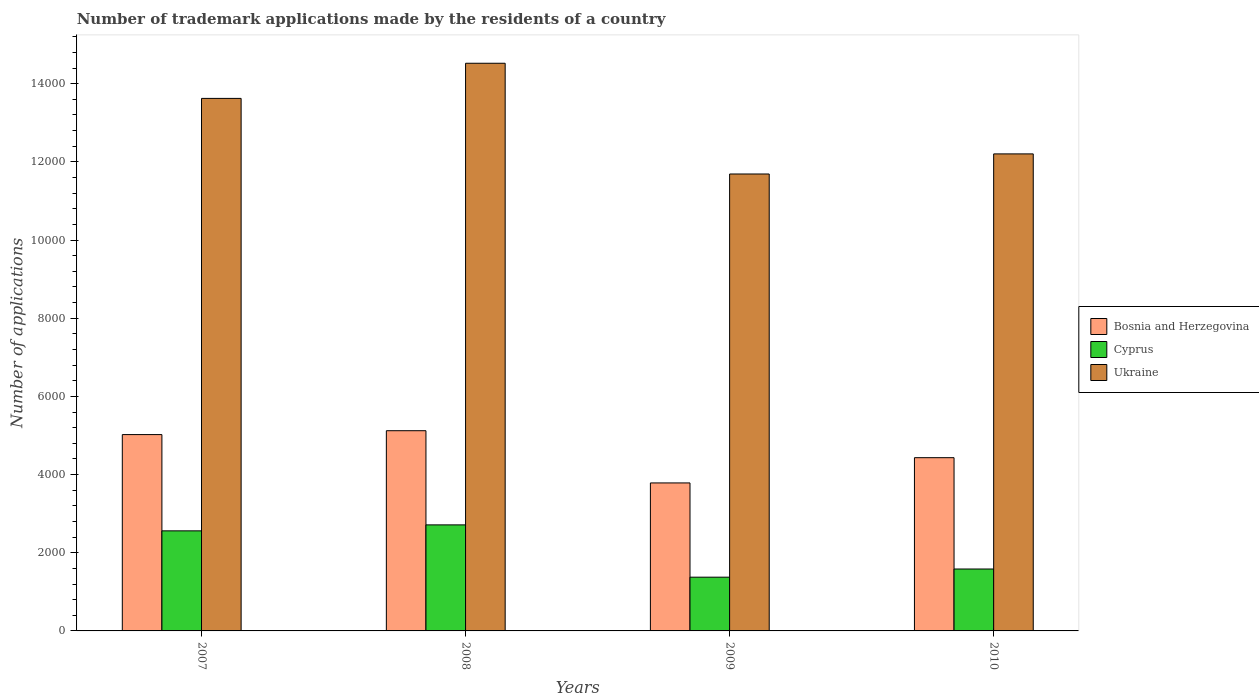Are the number of bars per tick equal to the number of legend labels?
Offer a very short reply. Yes. Are the number of bars on each tick of the X-axis equal?
Provide a succinct answer. Yes. How many bars are there on the 1st tick from the right?
Your response must be concise. 3. In how many cases, is the number of bars for a given year not equal to the number of legend labels?
Give a very brief answer. 0. What is the number of trademark applications made by the residents in Ukraine in 2008?
Make the answer very short. 1.45e+04. Across all years, what is the maximum number of trademark applications made by the residents in Cyprus?
Offer a terse response. 2713. Across all years, what is the minimum number of trademark applications made by the residents in Cyprus?
Ensure brevity in your answer.  1375. What is the total number of trademark applications made by the residents in Bosnia and Herzegovina in the graph?
Make the answer very short. 1.84e+04. What is the difference between the number of trademark applications made by the residents in Cyprus in 2008 and that in 2009?
Your answer should be very brief. 1338. What is the difference between the number of trademark applications made by the residents in Bosnia and Herzegovina in 2010 and the number of trademark applications made by the residents in Cyprus in 2009?
Keep it short and to the point. 3057. What is the average number of trademark applications made by the residents in Bosnia and Herzegovina per year?
Your response must be concise. 4590.75. In the year 2008, what is the difference between the number of trademark applications made by the residents in Ukraine and number of trademark applications made by the residents in Bosnia and Herzegovina?
Make the answer very short. 9401. In how many years, is the number of trademark applications made by the residents in Cyprus greater than 11200?
Provide a short and direct response. 0. What is the ratio of the number of trademark applications made by the residents in Cyprus in 2007 to that in 2010?
Offer a terse response. 1.62. What is the difference between the highest and the second highest number of trademark applications made by the residents in Cyprus?
Keep it short and to the point. 153. What is the difference between the highest and the lowest number of trademark applications made by the residents in Cyprus?
Your response must be concise. 1338. In how many years, is the number of trademark applications made by the residents in Ukraine greater than the average number of trademark applications made by the residents in Ukraine taken over all years?
Your response must be concise. 2. What does the 3rd bar from the left in 2009 represents?
Offer a very short reply. Ukraine. What does the 3rd bar from the right in 2007 represents?
Make the answer very short. Bosnia and Herzegovina. Are all the bars in the graph horizontal?
Provide a short and direct response. No. How many years are there in the graph?
Your response must be concise. 4. What is the difference between two consecutive major ticks on the Y-axis?
Provide a succinct answer. 2000. Does the graph contain any zero values?
Offer a terse response. No. Does the graph contain grids?
Provide a short and direct response. No. Where does the legend appear in the graph?
Provide a short and direct response. Center right. How many legend labels are there?
Ensure brevity in your answer.  3. What is the title of the graph?
Keep it short and to the point. Number of trademark applications made by the residents of a country. Does "North America" appear as one of the legend labels in the graph?
Provide a short and direct response. No. What is the label or title of the X-axis?
Give a very brief answer. Years. What is the label or title of the Y-axis?
Give a very brief answer. Number of applications. What is the Number of applications of Bosnia and Herzegovina in 2007?
Give a very brief answer. 5023. What is the Number of applications of Cyprus in 2007?
Provide a short and direct response. 2560. What is the Number of applications of Ukraine in 2007?
Provide a short and direct response. 1.36e+04. What is the Number of applications in Bosnia and Herzegovina in 2008?
Your answer should be very brief. 5122. What is the Number of applications in Cyprus in 2008?
Your response must be concise. 2713. What is the Number of applications of Ukraine in 2008?
Offer a terse response. 1.45e+04. What is the Number of applications of Bosnia and Herzegovina in 2009?
Your answer should be very brief. 3786. What is the Number of applications in Cyprus in 2009?
Your response must be concise. 1375. What is the Number of applications of Ukraine in 2009?
Keep it short and to the point. 1.17e+04. What is the Number of applications in Bosnia and Herzegovina in 2010?
Offer a very short reply. 4432. What is the Number of applications of Cyprus in 2010?
Provide a succinct answer. 1584. What is the Number of applications of Ukraine in 2010?
Make the answer very short. 1.22e+04. Across all years, what is the maximum Number of applications of Bosnia and Herzegovina?
Offer a very short reply. 5122. Across all years, what is the maximum Number of applications of Cyprus?
Your response must be concise. 2713. Across all years, what is the maximum Number of applications in Ukraine?
Provide a succinct answer. 1.45e+04. Across all years, what is the minimum Number of applications in Bosnia and Herzegovina?
Offer a terse response. 3786. Across all years, what is the minimum Number of applications of Cyprus?
Keep it short and to the point. 1375. Across all years, what is the minimum Number of applications of Ukraine?
Offer a terse response. 1.17e+04. What is the total Number of applications in Bosnia and Herzegovina in the graph?
Make the answer very short. 1.84e+04. What is the total Number of applications of Cyprus in the graph?
Your answer should be compact. 8232. What is the total Number of applications in Ukraine in the graph?
Make the answer very short. 5.20e+04. What is the difference between the Number of applications of Bosnia and Herzegovina in 2007 and that in 2008?
Your answer should be compact. -99. What is the difference between the Number of applications of Cyprus in 2007 and that in 2008?
Your answer should be very brief. -153. What is the difference between the Number of applications of Ukraine in 2007 and that in 2008?
Keep it short and to the point. -899. What is the difference between the Number of applications of Bosnia and Herzegovina in 2007 and that in 2009?
Give a very brief answer. 1237. What is the difference between the Number of applications in Cyprus in 2007 and that in 2009?
Your answer should be compact. 1185. What is the difference between the Number of applications of Ukraine in 2007 and that in 2009?
Your answer should be compact. 1934. What is the difference between the Number of applications in Bosnia and Herzegovina in 2007 and that in 2010?
Keep it short and to the point. 591. What is the difference between the Number of applications in Cyprus in 2007 and that in 2010?
Ensure brevity in your answer.  976. What is the difference between the Number of applications of Ukraine in 2007 and that in 2010?
Offer a very short reply. 1420. What is the difference between the Number of applications in Bosnia and Herzegovina in 2008 and that in 2009?
Provide a succinct answer. 1336. What is the difference between the Number of applications in Cyprus in 2008 and that in 2009?
Provide a succinct answer. 1338. What is the difference between the Number of applications of Ukraine in 2008 and that in 2009?
Provide a succinct answer. 2833. What is the difference between the Number of applications of Bosnia and Herzegovina in 2008 and that in 2010?
Your answer should be very brief. 690. What is the difference between the Number of applications of Cyprus in 2008 and that in 2010?
Make the answer very short. 1129. What is the difference between the Number of applications of Ukraine in 2008 and that in 2010?
Offer a very short reply. 2319. What is the difference between the Number of applications of Bosnia and Herzegovina in 2009 and that in 2010?
Give a very brief answer. -646. What is the difference between the Number of applications of Cyprus in 2009 and that in 2010?
Your response must be concise. -209. What is the difference between the Number of applications in Ukraine in 2009 and that in 2010?
Ensure brevity in your answer.  -514. What is the difference between the Number of applications of Bosnia and Herzegovina in 2007 and the Number of applications of Cyprus in 2008?
Provide a succinct answer. 2310. What is the difference between the Number of applications in Bosnia and Herzegovina in 2007 and the Number of applications in Ukraine in 2008?
Offer a terse response. -9500. What is the difference between the Number of applications in Cyprus in 2007 and the Number of applications in Ukraine in 2008?
Your answer should be compact. -1.20e+04. What is the difference between the Number of applications in Bosnia and Herzegovina in 2007 and the Number of applications in Cyprus in 2009?
Provide a short and direct response. 3648. What is the difference between the Number of applications of Bosnia and Herzegovina in 2007 and the Number of applications of Ukraine in 2009?
Your answer should be compact. -6667. What is the difference between the Number of applications of Cyprus in 2007 and the Number of applications of Ukraine in 2009?
Offer a very short reply. -9130. What is the difference between the Number of applications in Bosnia and Herzegovina in 2007 and the Number of applications in Cyprus in 2010?
Provide a short and direct response. 3439. What is the difference between the Number of applications of Bosnia and Herzegovina in 2007 and the Number of applications of Ukraine in 2010?
Provide a succinct answer. -7181. What is the difference between the Number of applications of Cyprus in 2007 and the Number of applications of Ukraine in 2010?
Provide a succinct answer. -9644. What is the difference between the Number of applications in Bosnia and Herzegovina in 2008 and the Number of applications in Cyprus in 2009?
Your response must be concise. 3747. What is the difference between the Number of applications in Bosnia and Herzegovina in 2008 and the Number of applications in Ukraine in 2009?
Your answer should be compact. -6568. What is the difference between the Number of applications in Cyprus in 2008 and the Number of applications in Ukraine in 2009?
Your answer should be very brief. -8977. What is the difference between the Number of applications of Bosnia and Herzegovina in 2008 and the Number of applications of Cyprus in 2010?
Provide a short and direct response. 3538. What is the difference between the Number of applications in Bosnia and Herzegovina in 2008 and the Number of applications in Ukraine in 2010?
Give a very brief answer. -7082. What is the difference between the Number of applications in Cyprus in 2008 and the Number of applications in Ukraine in 2010?
Your answer should be compact. -9491. What is the difference between the Number of applications in Bosnia and Herzegovina in 2009 and the Number of applications in Cyprus in 2010?
Offer a terse response. 2202. What is the difference between the Number of applications of Bosnia and Herzegovina in 2009 and the Number of applications of Ukraine in 2010?
Offer a very short reply. -8418. What is the difference between the Number of applications of Cyprus in 2009 and the Number of applications of Ukraine in 2010?
Your answer should be very brief. -1.08e+04. What is the average Number of applications in Bosnia and Herzegovina per year?
Offer a terse response. 4590.75. What is the average Number of applications in Cyprus per year?
Provide a succinct answer. 2058. What is the average Number of applications of Ukraine per year?
Provide a succinct answer. 1.30e+04. In the year 2007, what is the difference between the Number of applications in Bosnia and Herzegovina and Number of applications in Cyprus?
Offer a very short reply. 2463. In the year 2007, what is the difference between the Number of applications of Bosnia and Herzegovina and Number of applications of Ukraine?
Your answer should be very brief. -8601. In the year 2007, what is the difference between the Number of applications of Cyprus and Number of applications of Ukraine?
Provide a succinct answer. -1.11e+04. In the year 2008, what is the difference between the Number of applications in Bosnia and Herzegovina and Number of applications in Cyprus?
Offer a terse response. 2409. In the year 2008, what is the difference between the Number of applications in Bosnia and Herzegovina and Number of applications in Ukraine?
Your answer should be compact. -9401. In the year 2008, what is the difference between the Number of applications in Cyprus and Number of applications in Ukraine?
Keep it short and to the point. -1.18e+04. In the year 2009, what is the difference between the Number of applications in Bosnia and Herzegovina and Number of applications in Cyprus?
Give a very brief answer. 2411. In the year 2009, what is the difference between the Number of applications in Bosnia and Herzegovina and Number of applications in Ukraine?
Your answer should be very brief. -7904. In the year 2009, what is the difference between the Number of applications in Cyprus and Number of applications in Ukraine?
Offer a very short reply. -1.03e+04. In the year 2010, what is the difference between the Number of applications in Bosnia and Herzegovina and Number of applications in Cyprus?
Keep it short and to the point. 2848. In the year 2010, what is the difference between the Number of applications of Bosnia and Herzegovina and Number of applications of Ukraine?
Your response must be concise. -7772. In the year 2010, what is the difference between the Number of applications in Cyprus and Number of applications in Ukraine?
Provide a short and direct response. -1.06e+04. What is the ratio of the Number of applications in Bosnia and Herzegovina in 2007 to that in 2008?
Give a very brief answer. 0.98. What is the ratio of the Number of applications of Cyprus in 2007 to that in 2008?
Provide a short and direct response. 0.94. What is the ratio of the Number of applications in Ukraine in 2007 to that in 2008?
Give a very brief answer. 0.94. What is the ratio of the Number of applications of Bosnia and Herzegovina in 2007 to that in 2009?
Your response must be concise. 1.33. What is the ratio of the Number of applications of Cyprus in 2007 to that in 2009?
Your response must be concise. 1.86. What is the ratio of the Number of applications in Ukraine in 2007 to that in 2009?
Offer a very short reply. 1.17. What is the ratio of the Number of applications in Bosnia and Herzegovina in 2007 to that in 2010?
Offer a very short reply. 1.13. What is the ratio of the Number of applications in Cyprus in 2007 to that in 2010?
Make the answer very short. 1.62. What is the ratio of the Number of applications of Ukraine in 2007 to that in 2010?
Make the answer very short. 1.12. What is the ratio of the Number of applications of Bosnia and Herzegovina in 2008 to that in 2009?
Offer a very short reply. 1.35. What is the ratio of the Number of applications of Cyprus in 2008 to that in 2009?
Make the answer very short. 1.97. What is the ratio of the Number of applications of Ukraine in 2008 to that in 2009?
Your answer should be very brief. 1.24. What is the ratio of the Number of applications in Bosnia and Herzegovina in 2008 to that in 2010?
Your answer should be compact. 1.16. What is the ratio of the Number of applications of Cyprus in 2008 to that in 2010?
Ensure brevity in your answer.  1.71. What is the ratio of the Number of applications in Ukraine in 2008 to that in 2010?
Offer a very short reply. 1.19. What is the ratio of the Number of applications of Bosnia and Herzegovina in 2009 to that in 2010?
Offer a terse response. 0.85. What is the ratio of the Number of applications of Cyprus in 2009 to that in 2010?
Offer a very short reply. 0.87. What is the ratio of the Number of applications of Ukraine in 2009 to that in 2010?
Provide a short and direct response. 0.96. What is the difference between the highest and the second highest Number of applications in Cyprus?
Provide a short and direct response. 153. What is the difference between the highest and the second highest Number of applications in Ukraine?
Give a very brief answer. 899. What is the difference between the highest and the lowest Number of applications of Bosnia and Herzegovina?
Offer a terse response. 1336. What is the difference between the highest and the lowest Number of applications of Cyprus?
Offer a terse response. 1338. What is the difference between the highest and the lowest Number of applications in Ukraine?
Provide a succinct answer. 2833. 